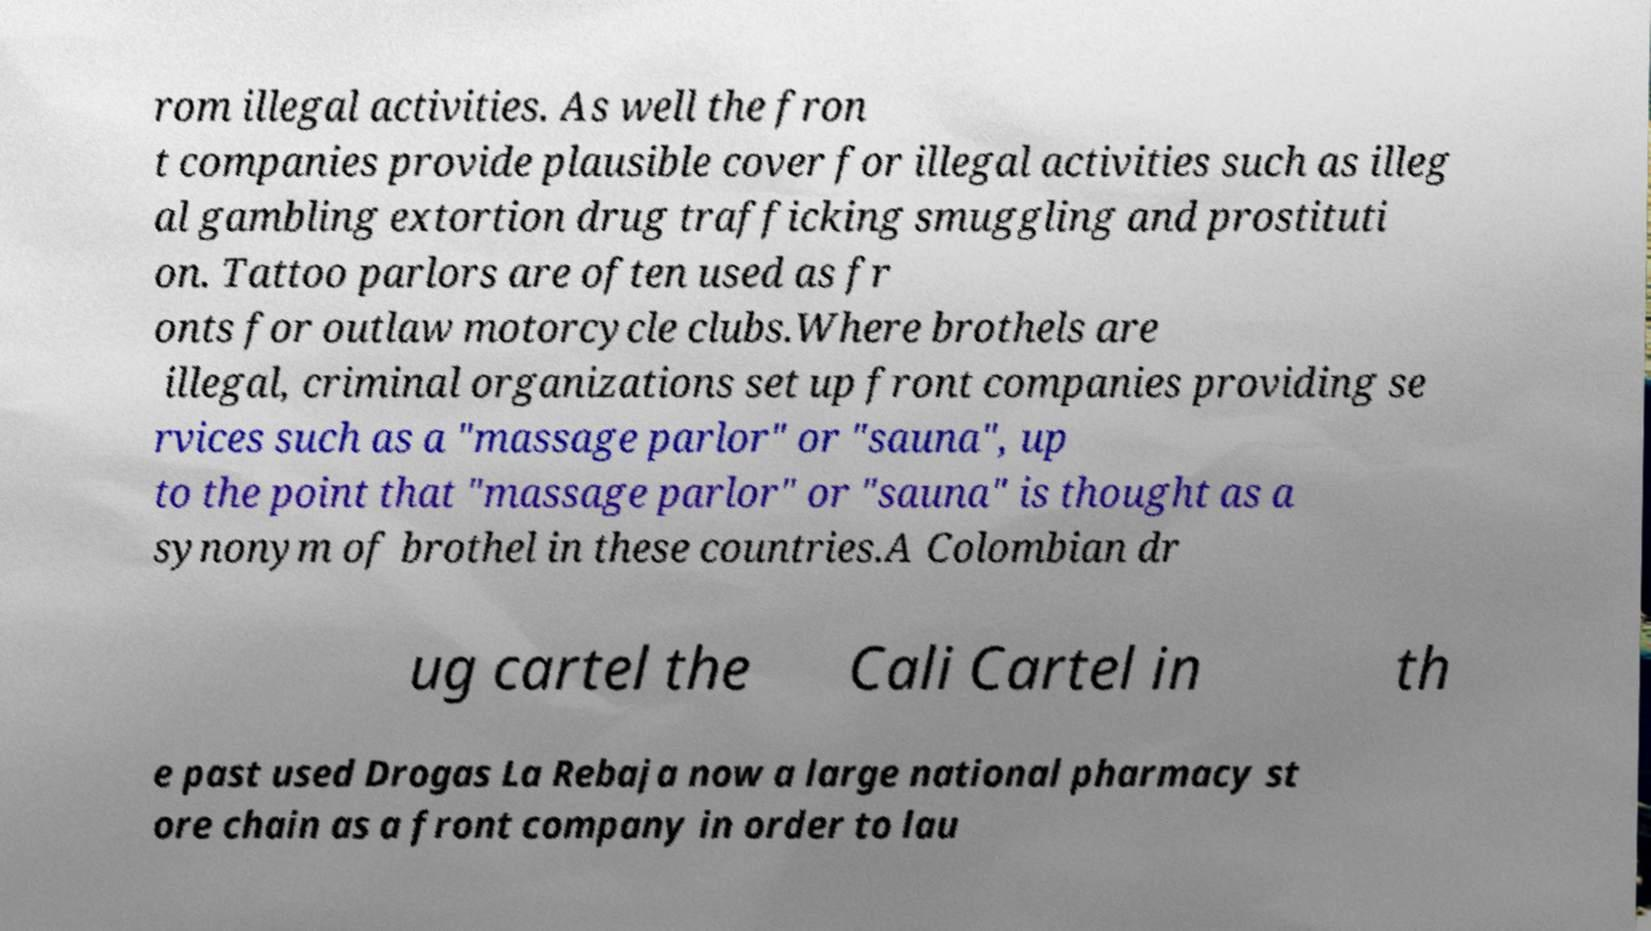I need the written content from this picture converted into text. Can you do that? rom illegal activities. As well the fron t companies provide plausible cover for illegal activities such as illeg al gambling extortion drug trafficking smuggling and prostituti on. Tattoo parlors are often used as fr onts for outlaw motorcycle clubs.Where brothels are illegal, criminal organizations set up front companies providing se rvices such as a "massage parlor" or "sauna", up to the point that "massage parlor" or "sauna" is thought as a synonym of brothel in these countries.A Colombian dr ug cartel the Cali Cartel in th e past used Drogas La Rebaja now a large national pharmacy st ore chain as a front company in order to lau 